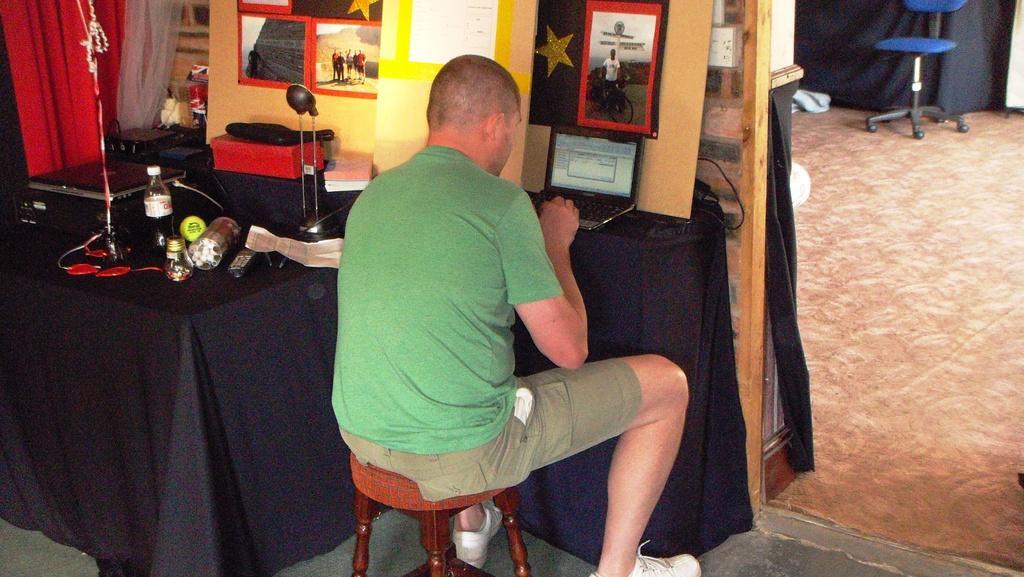Could you give a brief overview of what you see in this image? In the picture we can see inside the house a man sitting on the stool and doing work in the laptop and besides, we can see some things are placed on the table like laptop, books, bottle and behind it, we can see a wall with photo frames on it and beside it, we can see two curtains which are red and white in color and beside the man we can see another room in it we can see a floor mat and far away we can see a chair. 